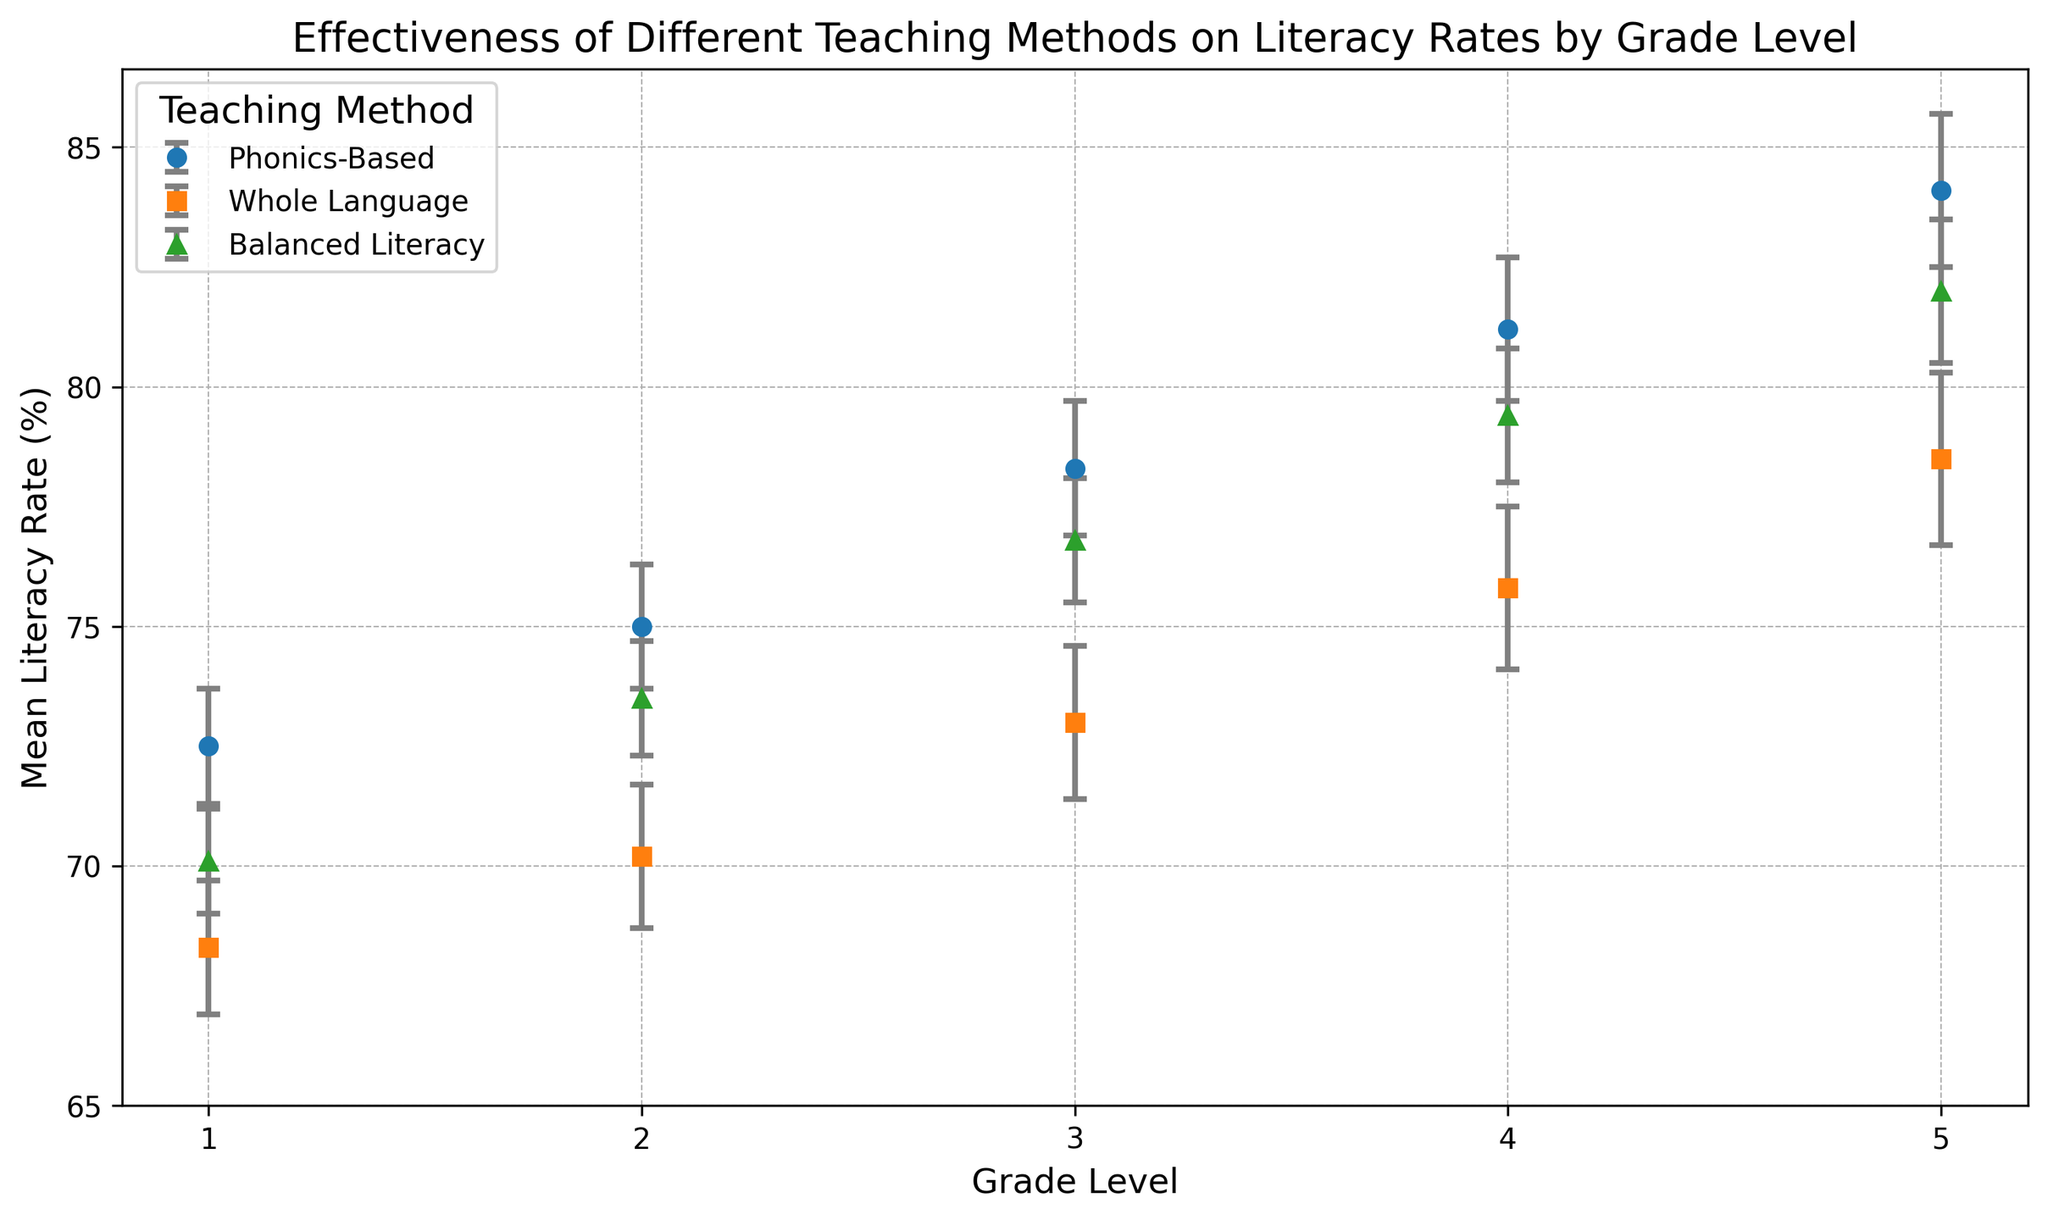Which teaching method has the highest mean literacy rate in Grade 1? Phonics-Based has the highest mean literacy rate in Grade 1. Comparing the data points for Grade 1, Phonics-Based is at 72.5%, Whole Language is at 68.3%, and Balanced Literacy is at 70.1%. Thus, Phonics-Based is the highest.
Answer: Phonics-Based How much higher is the mean literacy rate in Grade 2 for Phonics-Based compared to Whole Language? To find the difference, we subtract the mean literacy rate of Whole Language from that of Phonics-Based for Grade 2. Phonics-Based is at 75.0% and Whole Language is at 70.2%, so 75.0 - 70.2 = 4.8%.
Answer: 4.8% What is the average mean literacy rate of Balanced Literacy across all grade levels? To calculate the average, sum the mean literacy rates for Balanced Literacy across all grades and divide by the number of grades. (70.1 + 73.5 + 76.8 + 79.4 + 82.0) / 5 = 76.36%.
Answer: 76.36% Which grade level shows the largest standard error for Whole Language? By observing the error bars for Whole Language across all grades, Grade 5 has the largest standard error at 1.8. Other grades have smaller error values: 1.4 in Grade 1, 1.5 in Grade 2, 1.6 in Grade 3, and 1.7 in Grade 4.
Answer: Grade 5 Which teaching method has the smallest error bar in Grade 3, and how does it compare to the error bar of the same method in Grade 5? In Grade 3, Balanced Literacy has the smallest error bar at 1.3. In Grade 5, the same method has an error bar of 1.5. The comparison shows that the error bar for Grade 3 is smaller by 0.2.
Answer: Balanced Literacy, 0.2 smaller What is the total mean literacy rate for Phonics-Based across all grades? Adding the mean literacy rates for Phonics-Based across all grades: 72.5 + 75.0 + 78.3 + 81.2 + 84.1 = 391.1%.
Answer: 391.1% Which grade level shows the closest mean literacy rates among all three teaching methods? Grade 2 has the closest mean literacy rates: Phonics-Based at 75.0%, Whole Language at 70.2%, and Balanced Literacy at 73.5%. The differences are smaller compared to other grades.
Answer: Grade 2 Is the mean literacy rate for Whole Language consistently lower than that of Balanced Literacy in each grade level? Yes, for each grade level, Whole Language always has a lower mean literacy rate compared to Balanced Literacy: Grade 1: 68.3 < 70.1, Grade 2: 70.2 < 73.5, Grade 3: 73.0 < 76.8, Grade 4: 75.8 < 79.4, Grade 5: 78.5 < 82.0.
Answer: Yes 